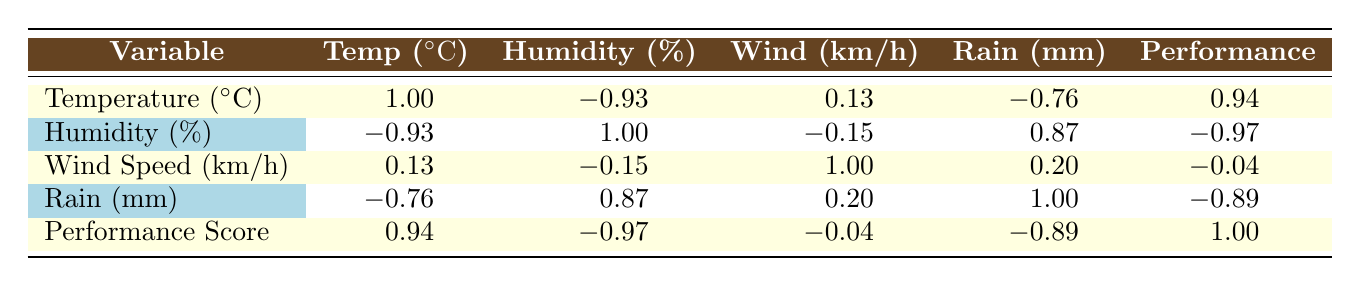What is the performance score when the temperature is 30 degrees Celsius? By scanning the table, the performance score corresponding to 30 degrees Celsius is noted in the performance score row for that temperature, which is 9.0.
Answer: 9.0 What is the correlation between humidity and performance score? The correlation value between humidity and performance score is found in the intersection of their respective rows and columns, which is -0.97.
Answer: -0.97 What is the highest performance score recorded in the data? To find the highest performance score, we can review the performance score column and see that the maximum value listed is 9.0.
Answer: 9.0 Is the performance score directly affected by increased rainfall? Observing the correlation value between rain and performance score, which is -0.89, indicates a strong negative relationship suggesting that increased rainfall likely leads to decreased performance scores.
Answer: Yes What is the average temperature of the data set? First, we gather the temperature values: 20, 5, 30, 15, -5, 25, and 10. Adding these gives 100, and since there are 7 entries, the average is 100/7 = approximately 14.29.
Answer: 14.3 Which weather condition has the lowest performance score and what is it? In reviewing the performance score column, the lowest score is 3.0 associated with a temperature of -5 degrees Celsius, high humidity, and significant rainfall.
Answer: 3.0 What is the correlation between temperature and wind speed? The correlation value between temperature and wind speed can be found at the intersection of their respective rows and columns, which is 0.13, indicating a very weak positive correlation.
Answer: 0.13 Does increased humidity correlate positively with increased rainfall? By checking the correlation between humidity and rain, which is found to be 0.87, we can conclude that there is indeed a strong positive correlation, suggesting higher humidity often accompanies more rainfall.
Answer: Yes 